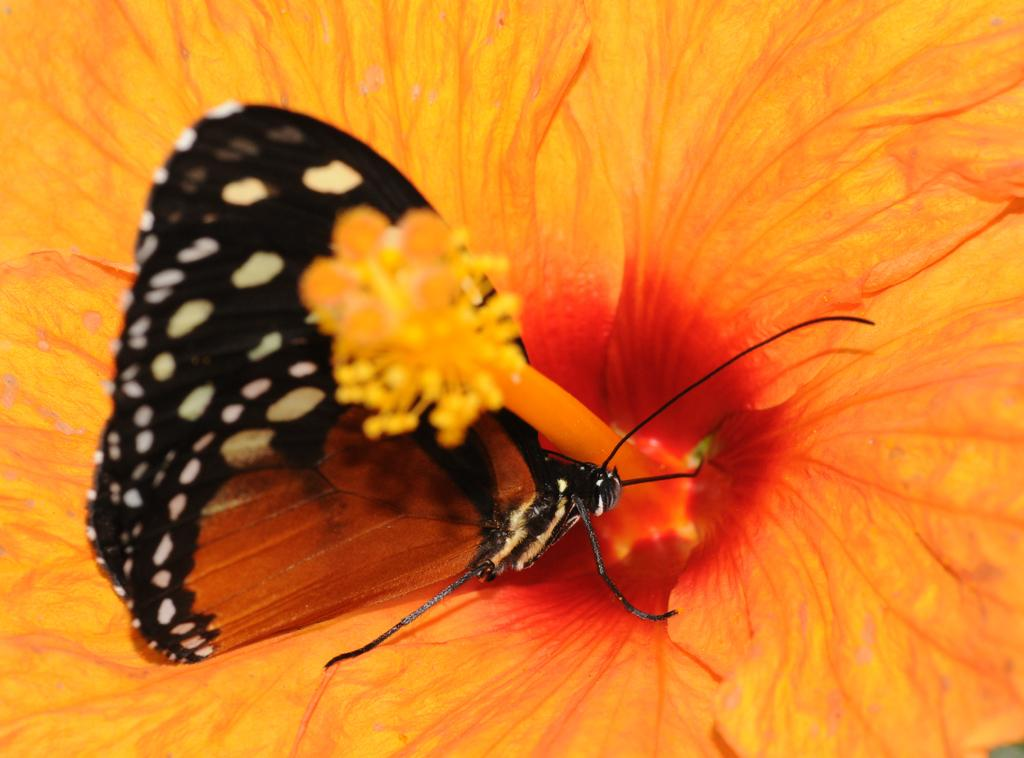What is the main subject of the image? There is a flower in the image. Can you describe the color of the flower? The flower is yellow in color. Are there any other living creatures in the image besides the flower? Yes, there is a butterfly in the image. Where is the butterfly located in relation to the flower? The butterfly is on the flower. What type of pets can be seen in the bedroom in the image? There is no bedroom or pets present in the image; it features a yellow flower with a butterfly on it. 